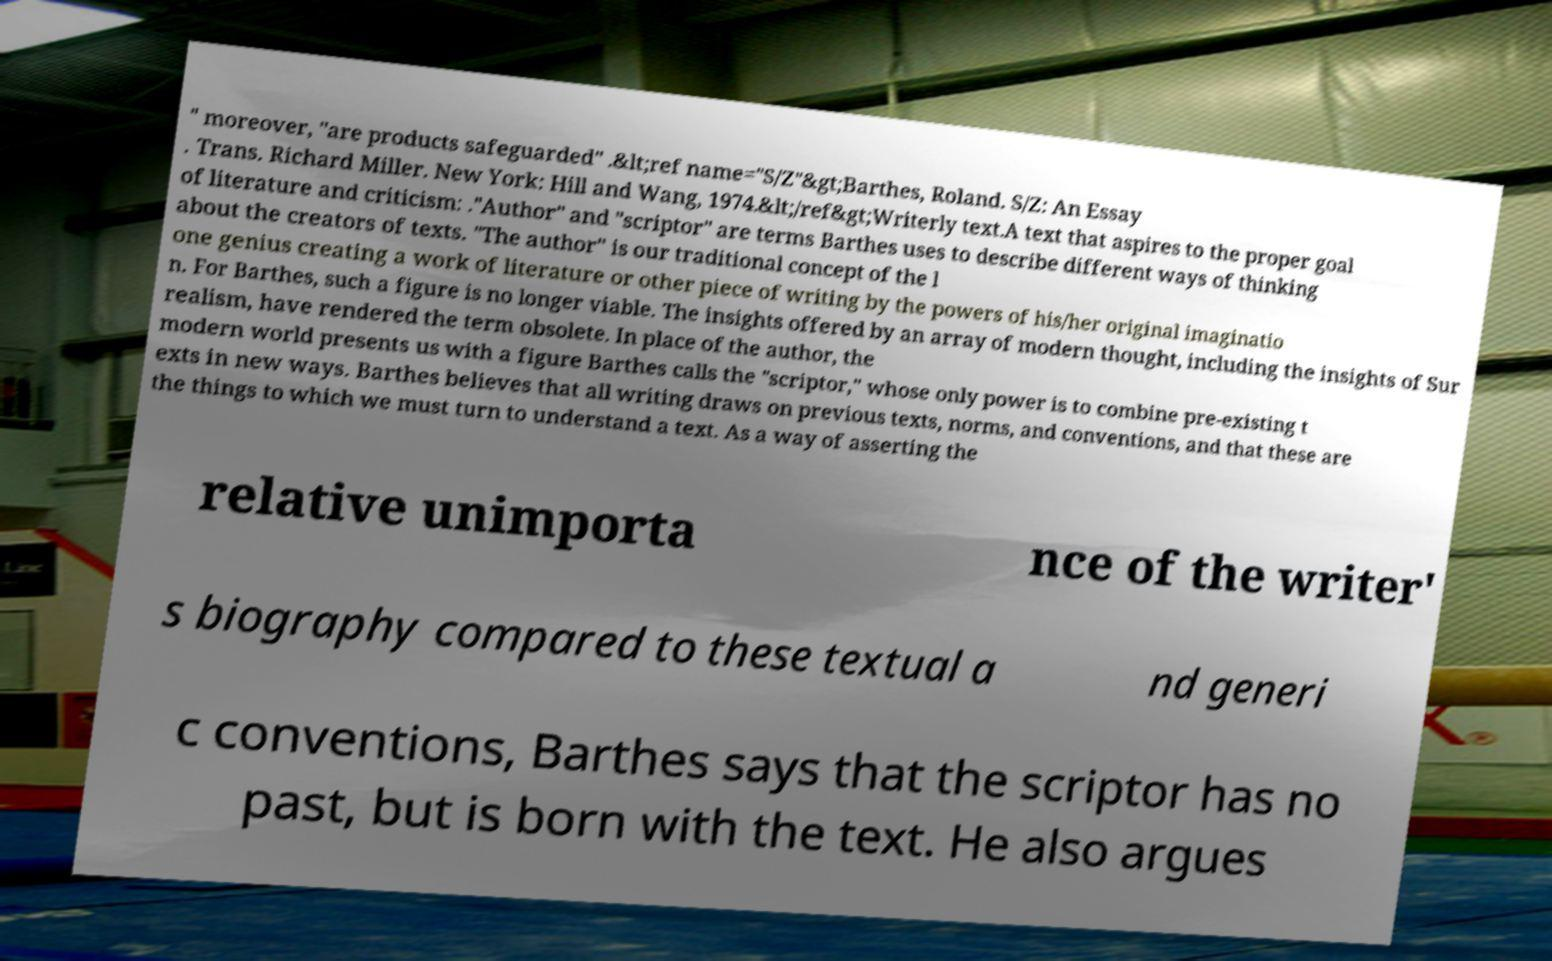I need the written content from this picture converted into text. Can you do that? " moreover, "are products safeguarded" .&lt;ref name="S/Z"&gt;Barthes, Roland. S/Z: An Essay . Trans. Richard Miller. New York: Hill and Wang, 1974.&lt;/ref&gt;Writerly text.A text that aspires to the proper goal of literature and criticism: ."Author" and "scriptor" are terms Barthes uses to describe different ways of thinking about the creators of texts. "The author" is our traditional concept of the l one genius creating a work of literature or other piece of writing by the powers of his/her original imaginatio n. For Barthes, such a figure is no longer viable. The insights offered by an array of modern thought, including the insights of Sur realism, have rendered the term obsolete. In place of the author, the modern world presents us with a figure Barthes calls the "scriptor," whose only power is to combine pre-existing t exts in new ways. Barthes believes that all writing draws on previous texts, norms, and conventions, and that these are the things to which we must turn to understand a text. As a way of asserting the relative unimporta nce of the writer' s biography compared to these textual a nd generi c conventions, Barthes says that the scriptor has no past, but is born with the text. He also argues 